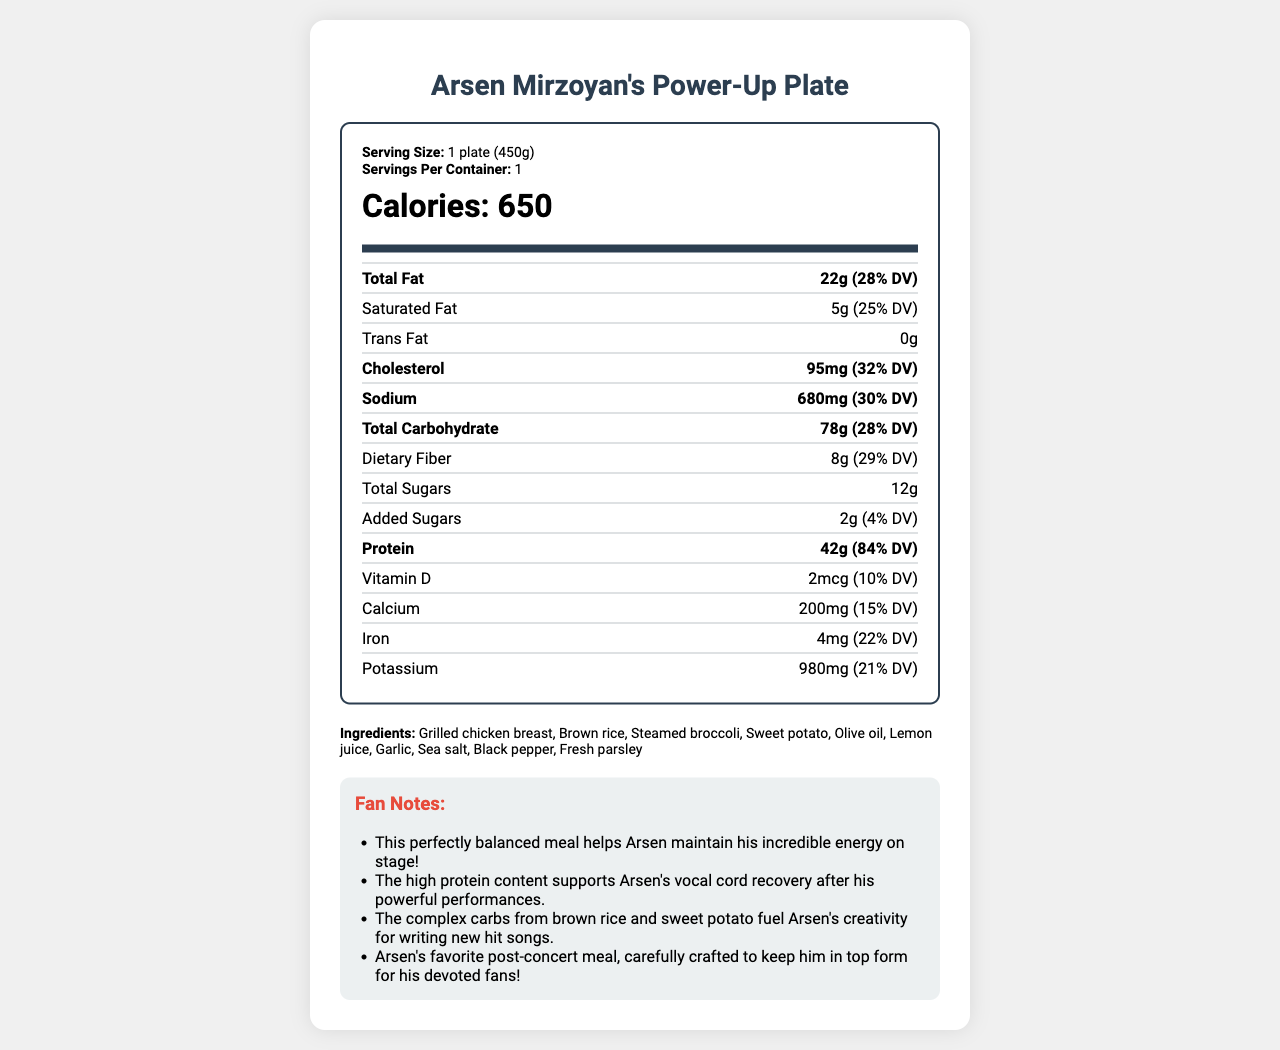What is the serving size of Arsen Mirzoyan's Power-Up Plate? The serving size is clearly stated as "1 plate (450g)" in the document.
Answer: 1 plate (450g) How many calories are in one serving of the Power-Up Plate? The calorie count is marked as 650 in large, bold text under the nutrition label section.
Answer: 650 What is the amount of protein in the Power-Up Plate, and what percentage of the daily value does it represent? The document lists protein as 42g, which is 84% of the daily value (% DV).
Answer: 42g, 84% DV Does the Power-Up Plate contain any trans fat? The trans fat amount is shown as 0g in the nutrition information.
Answer: No What ingredients are included in Arsen Mirzoyan's Power-Up Plate? The ingredients are listed towards the end of the document under the ingredients section.
Answer: Grilled chicken breast, Brown rice, Steamed broccoli, Sweet potato, Olive oil, Lemon juice, Garlic, Sea salt, Black pepper, Fresh parsley Which of the following nutrients has the highest daily value percentage in the Power-Up Plate? A. Vitamin D B. Calcium C. Protein D. Iron Protein has the highest daily value percentage at 84%, while Vitamin D is 10%, Calcium is 15%, and Iron is 22%.
Answer: C What is the total carbohydrate content in the Power-Up Plate, and what is its daily value percentage? A. 78g, 28% DV B. 42g, 84% DV C. 22g, 15% DV D. 12g, 4% DV The total carbohydrate content is listed as 78g with a daily value percentage of 28%.
Answer: A Does the Power-Up Plate contain any allergens? According to the document, the allergens section mentions "None".
Answer: No What is the potassium content in the Power-Up Plate? The potassium content is listed as 980mg in the nutrition facts.
Answer: 980mg Is Arsen Mirzoyan's Power-Up Plate vegetarian? The ingredients include grilled chicken breast, which is not vegetarian.
Answer: No Summarize the main nutritional benefits of Arsen Mirzoyan's Power-Up Plate. The document highlights that the meal is designed to support Arsen's energy and recovery, being rich in protein, complex carbs, and essential minerals like potassium and iron.
Answer: The Power-Up Plate is a balanced meal with 650 calories, high protein (42g, 84% DV), complex carbohydrates (78g, 28% DV), and essential minerals and vitamins. It supports Arsen Mirzoyan's energy and recovery post-concert. What is the exact amount of olive oil used in the Power-Up Plate? The document lists olive oil as an ingredient but does not specify the exact amount used.
Answer: Not enough information 